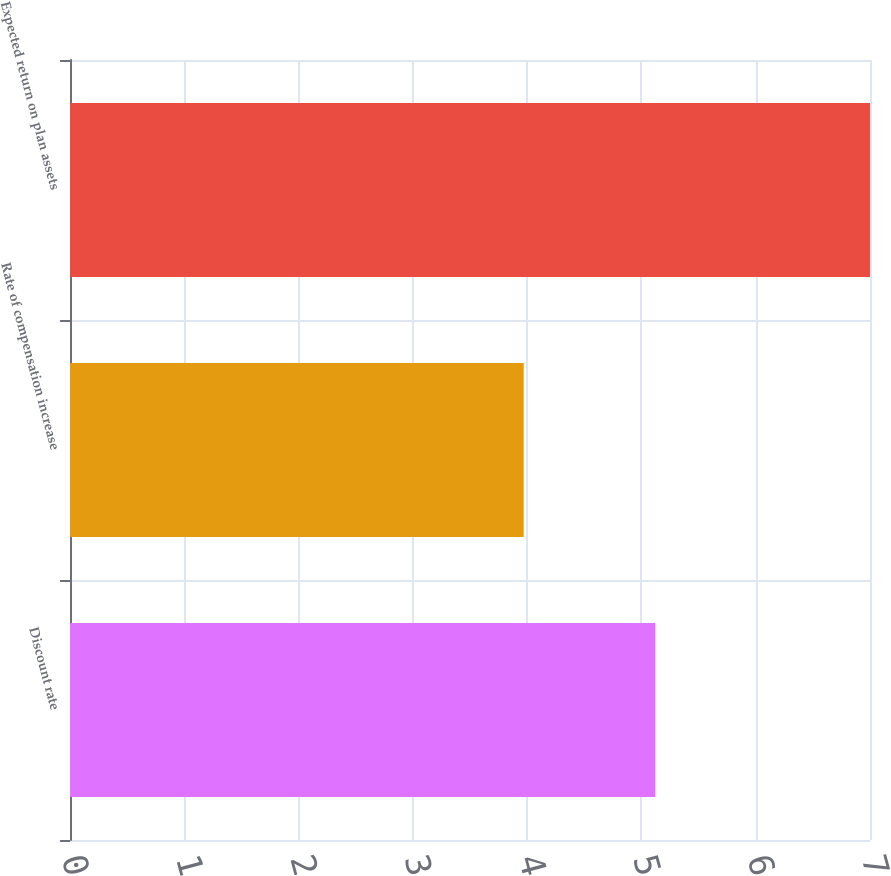Convert chart. <chart><loc_0><loc_0><loc_500><loc_500><bar_chart><fcel>Discount rate<fcel>Rate of compensation increase<fcel>Expected return on plan assets<nl><fcel>5.12<fcel>3.97<fcel>7<nl></chart> 